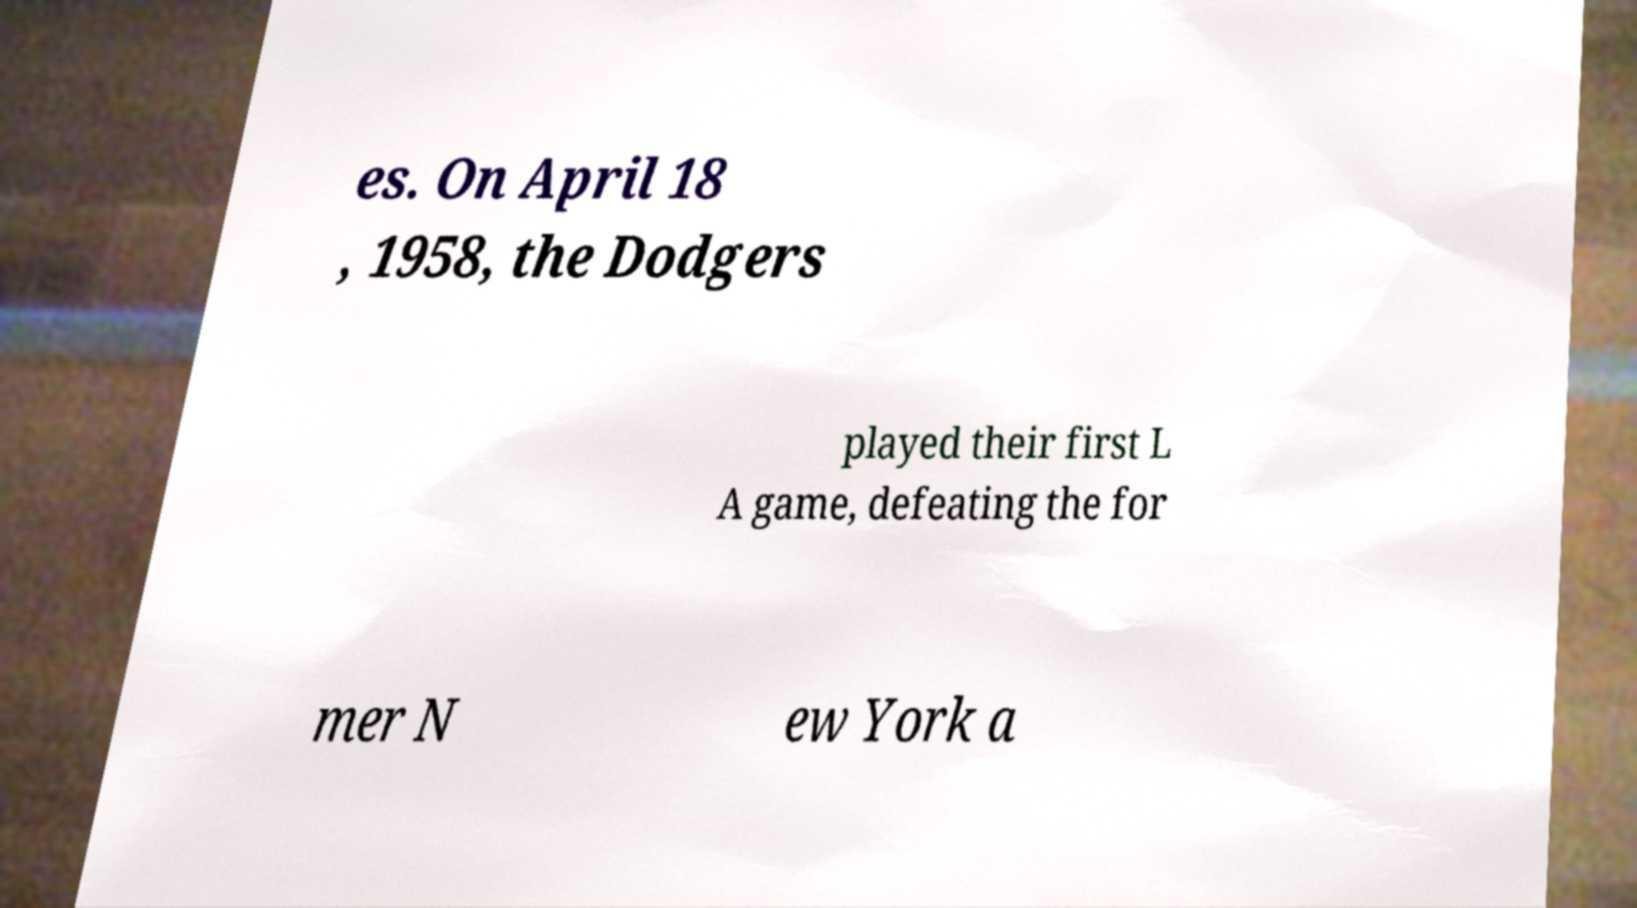Please identify and transcribe the text found in this image. es. On April 18 , 1958, the Dodgers played their first L A game, defeating the for mer N ew York a 